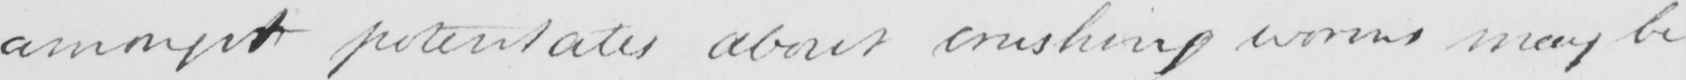Transcribe the text shown in this historical manuscript line. amongst potentates about crushing worms may be 